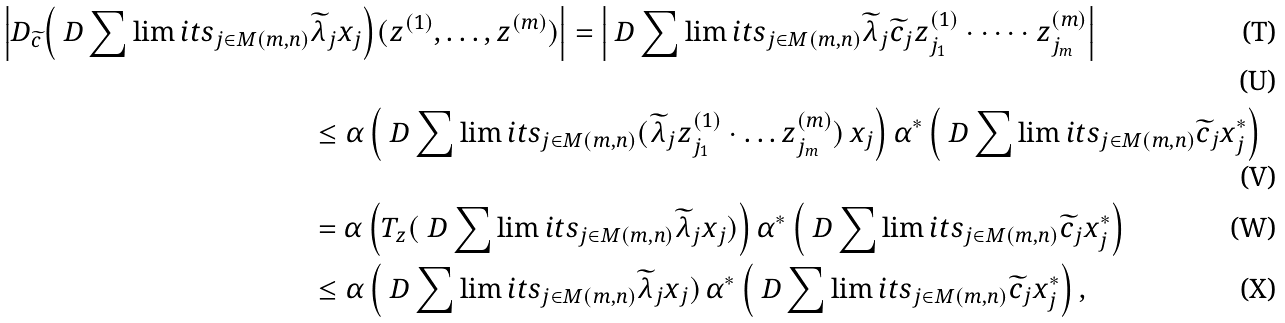<formula> <loc_0><loc_0><loc_500><loc_500>\Big | D _ { \widetilde { c } } \Big ( \ D \sum \lim i t s _ { j \in M ( m , n ) } & \widetilde { \lambda } _ { j } x _ { j } \Big ) ( z ^ { ( 1 ) } , \dots , z ^ { ( m ) } ) \Big | = \Big | \ D \sum \lim i t s _ { j \in M ( m , n ) } \widetilde { \lambda } _ { j } \widetilde { c } _ { j } z _ { j _ { 1 } } ^ { ( 1 ) } \cdot \dots \cdot z _ { j _ { m } } ^ { ( m ) } \Big | \\ \\ & \leq \alpha \, \Big ( \ D \sum \lim i t s _ { j \in M ( m , n ) } ( \widetilde { \lambda } _ { j } z _ { j _ { 1 } } ^ { ( 1 ) } \cdot \dots z _ { j _ { m } } ^ { ( m ) } ) \, x _ { j } \Big ) \, \alpha ^ { \ast } \, \Big ( \ D \sum \lim i t s _ { j \in M ( m , n ) } \widetilde { c } _ { j } x _ { j } ^ { \ast } \Big ) \\ & = \alpha \, \Big ( T _ { z } ( \ D \sum \lim i t s _ { j \in M ( m , n ) } \widetilde { \lambda } _ { j } x _ { j } ) \Big ) \, \alpha ^ { \ast } \, \Big ( \ D \sum \lim i t s _ { j \in M ( m , n ) } \widetilde { c } _ { j } x _ { j } ^ { \ast } \Big ) \\ & \leq \alpha \, \Big ( \ D \sum \lim i t s _ { j \in M ( m , n ) } \widetilde { \lambda } _ { j } x _ { j } ) \, \alpha ^ { \ast } \, \Big ( \ D \sum \lim i t s _ { j \in M ( m , n ) } \widetilde { c } _ { j } x _ { j } ^ { \ast } \Big ) \, ,</formula> 